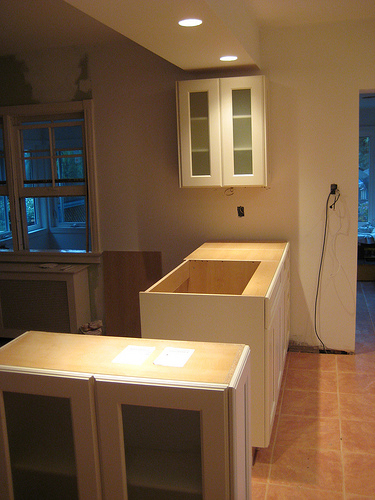<image>
Can you confirm if the cabinet is on the counter? No. The cabinet is not positioned on the counter. They may be near each other, but the cabinet is not supported by or resting on top of the counter. 